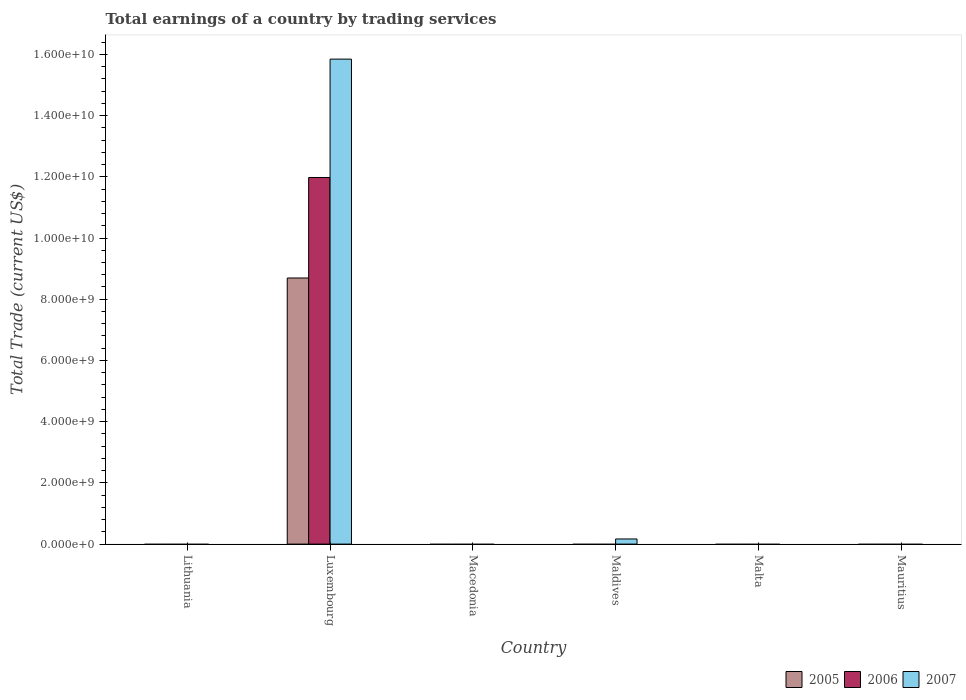How many bars are there on the 3rd tick from the left?
Offer a terse response. 0. How many bars are there on the 5th tick from the right?
Offer a terse response. 3. What is the label of the 2nd group of bars from the left?
Give a very brief answer. Luxembourg. Across all countries, what is the maximum total earnings in 2005?
Your answer should be very brief. 8.69e+09. Across all countries, what is the minimum total earnings in 2005?
Your answer should be compact. 0. In which country was the total earnings in 2007 maximum?
Your response must be concise. Luxembourg. What is the total total earnings in 2005 in the graph?
Provide a succinct answer. 8.69e+09. What is the average total earnings in 2007 per country?
Your answer should be very brief. 2.67e+09. What is the difference between the total earnings of/in 2007 and total earnings of/in 2005 in Luxembourg?
Give a very brief answer. 7.15e+09. In how many countries, is the total earnings in 2005 greater than 7200000000 US$?
Give a very brief answer. 1. What is the ratio of the total earnings in 2007 in Luxembourg to that in Maldives?
Offer a terse response. 94.2. What is the difference between the highest and the lowest total earnings in 2006?
Ensure brevity in your answer.  1.20e+1. In how many countries, is the total earnings in 2007 greater than the average total earnings in 2007 taken over all countries?
Offer a very short reply. 1. How many bars are there?
Provide a succinct answer. 4. How many countries are there in the graph?
Keep it short and to the point. 6. What is the difference between two consecutive major ticks on the Y-axis?
Keep it short and to the point. 2.00e+09. Are the values on the major ticks of Y-axis written in scientific E-notation?
Ensure brevity in your answer.  Yes. Does the graph contain grids?
Make the answer very short. No. What is the title of the graph?
Keep it short and to the point. Total earnings of a country by trading services. Does "1974" appear as one of the legend labels in the graph?
Offer a terse response. No. What is the label or title of the X-axis?
Ensure brevity in your answer.  Country. What is the label or title of the Y-axis?
Make the answer very short. Total Trade (current US$). What is the Total Trade (current US$) in 2007 in Lithuania?
Keep it short and to the point. 0. What is the Total Trade (current US$) in 2005 in Luxembourg?
Ensure brevity in your answer.  8.69e+09. What is the Total Trade (current US$) of 2006 in Luxembourg?
Your answer should be very brief. 1.20e+1. What is the Total Trade (current US$) in 2007 in Luxembourg?
Provide a succinct answer. 1.58e+1. What is the Total Trade (current US$) of 2005 in Macedonia?
Make the answer very short. 0. What is the Total Trade (current US$) in 2006 in Macedonia?
Offer a very short reply. 0. What is the Total Trade (current US$) in 2007 in Macedonia?
Provide a succinct answer. 0. What is the Total Trade (current US$) in 2005 in Maldives?
Give a very brief answer. 0. What is the Total Trade (current US$) in 2006 in Maldives?
Your answer should be very brief. 0. What is the Total Trade (current US$) of 2007 in Maldives?
Offer a very short reply. 1.68e+08. What is the Total Trade (current US$) of 2007 in Malta?
Provide a short and direct response. 0. What is the Total Trade (current US$) of 2005 in Mauritius?
Offer a very short reply. 0. Across all countries, what is the maximum Total Trade (current US$) in 2005?
Keep it short and to the point. 8.69e+09. Across all countries, what is the maximum Total Trade (current US$) of 2006?
Your response must be concise. 1.20e+1. Across all countries, what is the maximum Total Trade (current US$) in 2007?
Provide a succinct answer. 1.58e+1. Across all countries, what is the minimum Total Trade (current US$) in 2005?
Your answer should be very brief. 0. Across all countries, what is the minimum Total Trade (current US$) of 2006?
Offer a terse response. 0. What is the total Total Trade (current US$) of 2005 in the graph?
Make the answer very short. 8.69e+09. What is the total Total Trade (current US$) of 2006 in the graph?
Keep it short and to the point. 1.20e+1. What is the total Total Trade (current US$) in 2007 in the graph?
Your answer should be compact. 1.60e+1. What is the difference between the Total Trade (current US$) of 2007 in Luxembourg and that in Maldives?
Your answer should be very brief. 1.57e+1. What is the difference between the Total Trade (current US$) in 2005 in Luxembourg and the Total Trade (current US$) in 2007 in Maldives?
Offer a terse response. 8.53e+09. What is the difference between the Total Trade (current US$) in 2006 in Luxembourg and the Total Trade (current US$) in 2007 in Maldives?
Your answer should be compact. 1.18e+1. What is the average Total Trade (current US$) of 2005 per country?
Your answer should be compact. 1.45e+09. What is the average Total Trade (current US$) of 2006 per country?
Offer a very short reply. 2.00e+09. What is the average Total Trade (current US$) in 2007 per country?
Your answer should be compact. 2.67e+09. What is the difference between the Total Trade (current US$) of 2005 and Total Trade (current US$) of 2006 in Luxembourg?
Your response must be concise. -3.28e+09. What is the difference between the Total Trade (current US$) of 2005 and Total Trade (current US$) of 2007 in Luxembourg?
Ensure brevity in your answer.  -7.15e+09. What is the difference between the Total Trade (current US$) in 2006 and Total Trade (current US$) in 2007 in Luxembourg?
Make the answer very short. -3.87e+09. What is the ratio of the Total Trade (current US$) of 2007 in Luxembourg to that in Maldives?
Ensure brevity in your answer.  94.2. What is the difference between the highest and the lowest Total Trade (current US$) of 2005?
Make the answer very short. 8.69e+09. What is the difference between the highest and the lowest Total Trade (current US$) in 2006?
Give a very brief answer. 1.20e+1. What is the difference between the highest and the lowest Total Trade (current US$) in 2007?
Give a very brief answer. 1.58e+1. 